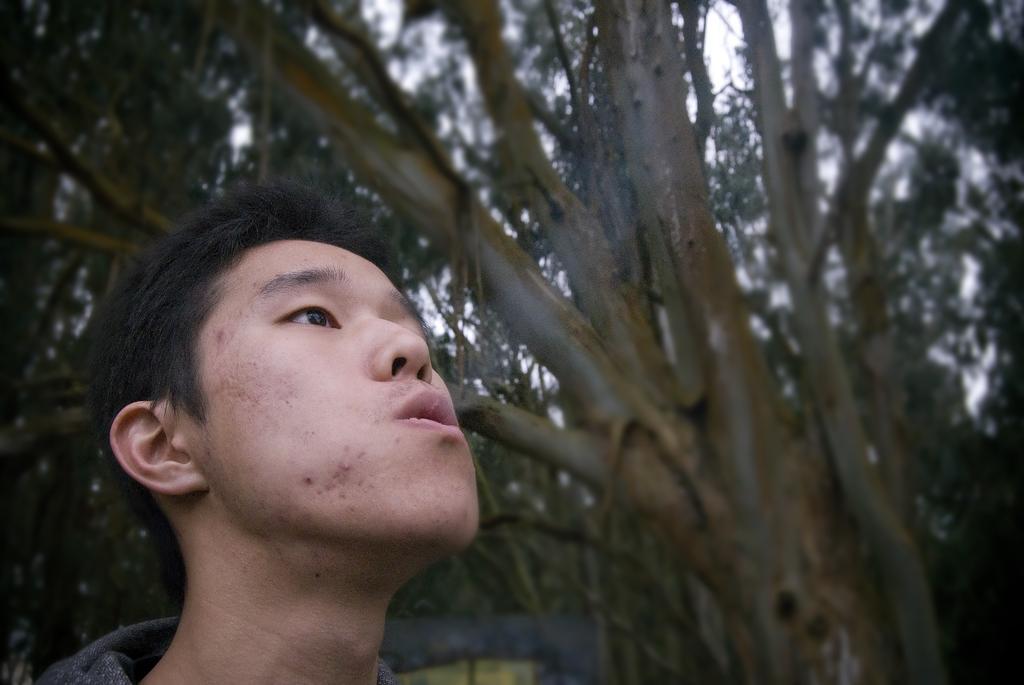Describe this image in one or two sentences. In the image I can see a man releasing smoke from the mouth at the back there are so many trees. 